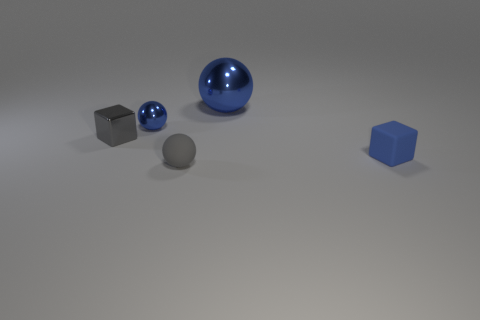There is a blue cube; is its size the same as the block on the left side of the blue rubber cube?
Offer a very short reply. Yes. There is a object that is both to the right of the tiny blue ball and behind the metal cube; how big is it?
Make the answer very short. Large. Are there any other big spheres made of the same material as the big blue sphere?
Provide a succinct answer. No. What is the shape of the large thing?
Keep it short and to the point. Sphere. Do the blue block and the gray shiny thing have the same size?
Provide a short and direct response. Yes. How many other objects are the same shape as the gray rubber object?
Offer a very short reply. 2. There is a tiny matte thing that is left of the blue matte object; what is its shape?
Offer a very short reply. Sphere. Is the shape of the tiny blue thing that is right of the small metal ball the same as the small matte object on the left side of the large blue ball?
Your response must be concise. No. Are there the same number of small cubes that are to the right of the gray rubber sphere and blue matte blocks?
Ensure brevity in your answer.  Yes. Is there any other thing that is the same size as the gray metallic thing?
Provide a short and direct response. Yes. 